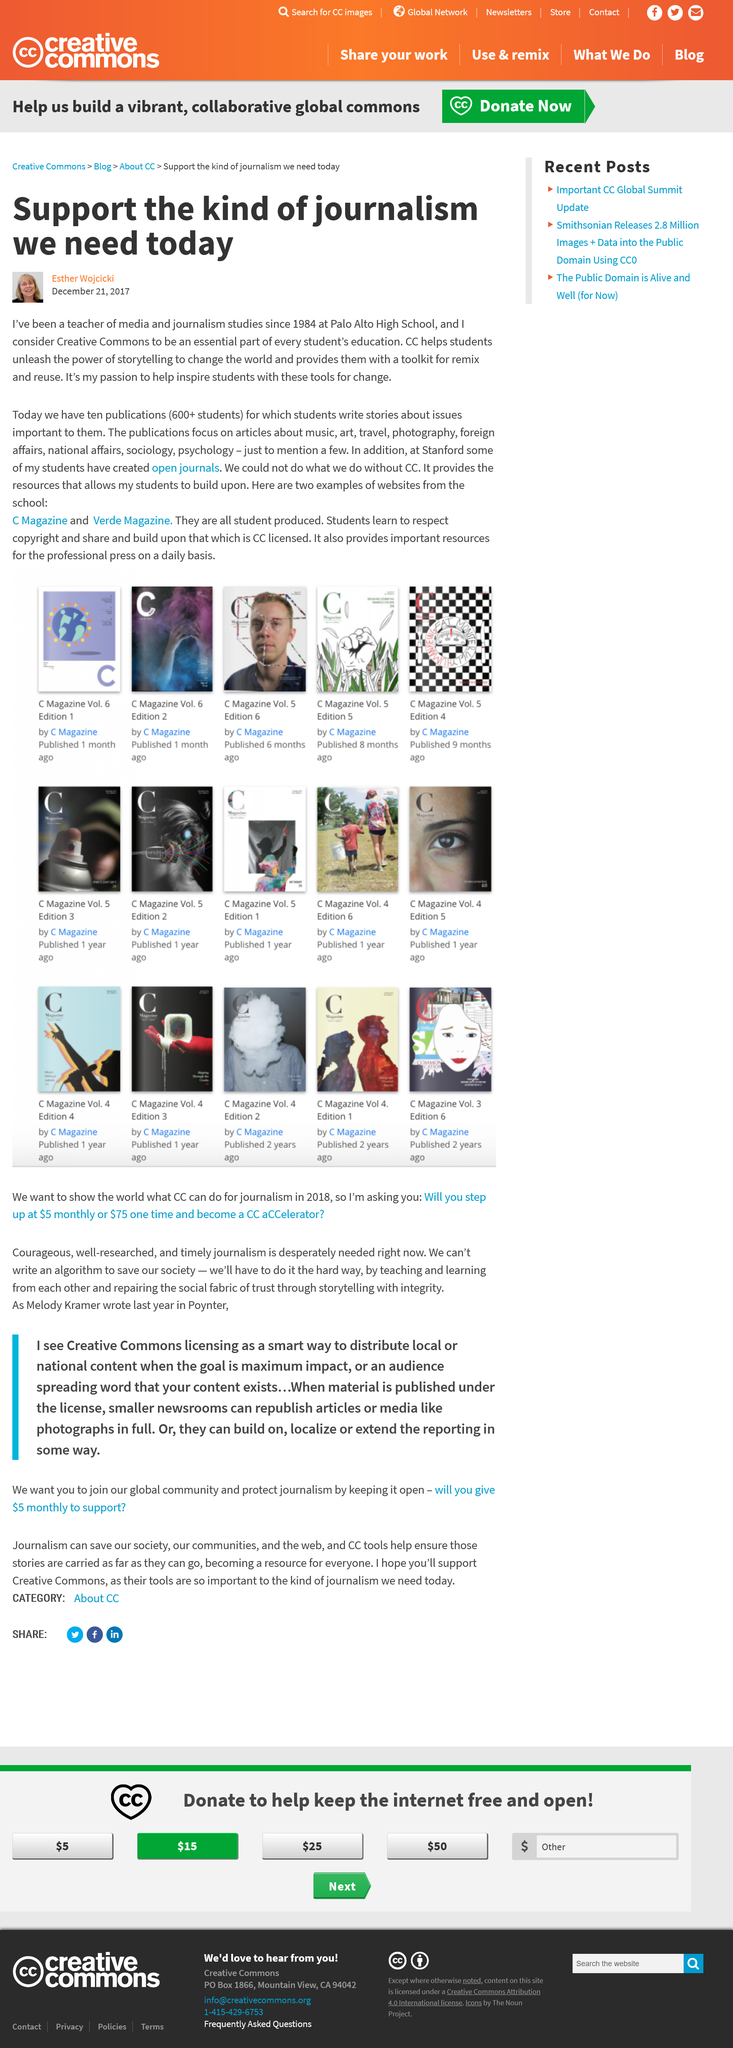List a handful of essential elements in this visual. This text was written on December 21st, 2017. Esther Wojcicki is the author of this writing. Since 1984, Esther has been a teacher of media and journalism at the Palo Alto High School. 